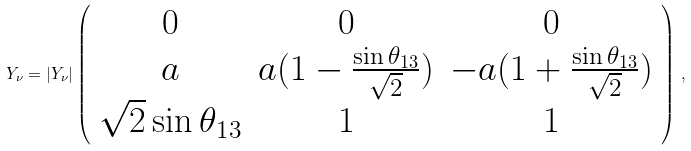<formula> <loc_0><loc_0><loc_500><loc_500>Y _ { \nu } = | Y _ { \nu } | \left ( \begin{array} { c c c } 0 & 0 & 0 \\ a & a ( 1 - \frac { \sin \theta _ { 1 3 } } { \sqrt { 2 } } ) & - a ( 1 + \frac { \sin \theta _ { 1 3 } } { \sqrt { 2 } } ) \\ \sqrt { 2 } \sin \theta _ { 1 3 } & 1 & 1 \\ \end{array} \right ) \, ,</formula> 